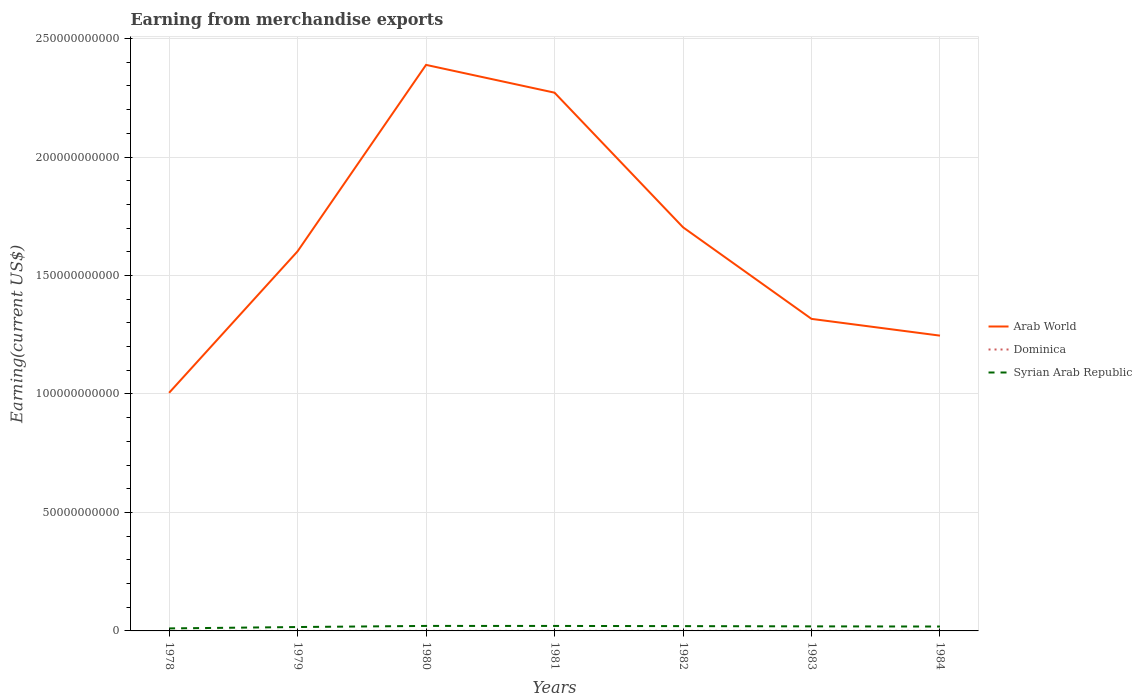Does the line corresponding to Dominica intersect with the line corresponding to Syrian Arab Republic?
Ensure brevity in your answer.  No. Is the number of lines equal to the number of legend labels?
Offer a terse response. Yes. Across all years, what is the maximum amount earned from merchandise exports in Syrian Arab Republic?
Keep it short and to the point. 1.06e+09. In which year was the amount earned from merchandise exports in Dominica maximum?
Your response must be concise. 1979. What is the total amount earned from merchandise exports in Dominica in the graph?
Provide a succinct answer. -1.70e+07. What is the difference between the highest and the second highest amount earned from merchandise exports in Dominica?
Make the answer very short. 1.76e+07. Is the amount earned from merchandise exports in Syrian Arab Republic strictly greater than the amount earned from merchandise exports in Dominica over the years?
Offer a terse response. No. How many lines are there?
Your answer should be very brief. 3. How many years are there in the graph?
Offer a terse response. 7. Does the graph contain grids?
Offer a terse response. Yes. What is the title of the graph?
Ensure brevity in your answer.  Earning from merchandise exports. What is the label or title of the Y-axis?
Your response must be concise. Earning(current US$). What is the Earning(current US$) in Arab World in 1978?
Provide a succinct answer. 1.00e+11. What is the Earning(current US$) of Dominica in 1978?
Ensure brevity in your answer.  1.59e+07. What is the Earning(current US$) of Syrian Arab Republic in 1978?
Make the answer very short. 1.06e+09. What is the Earning(current US$) in Arab World in 1979?
Make the answer very short. 1.60e+11. What is the Earning(current US$) in Dominica in 1979?
Keep it short and to the point. 9.40e+06. What is the Earning(current US$) in Syrian Arab Republic in 1979?
Offer a very short reply. 1.64e+09. What is the Earning(current US$) in Arab World in 1980?
Make the answer very short. 2.39e+11. What is the Earning(current US$) of Syrian Arab Republic in 1980?
Provide a succinct answer. 2.11e+09. What is the Earning(current US$) in Arab World in 1981?
Ensure brevity in your answer.  2.27e+11. What is the Earning(current US$) in Dominica in 1981?
Make the answer very short. 1.90e+07. What is the Earning(current US$) in Syrian Arab Republic in 1981?
Keep it short and to the point. 2.10e+09. What is the Earning(current US$) of Arab World in 1982?
Your response must be concise. 1.70e+11. What is the Earning(current US$) in Dominica in 1982?
Your answer should be very brief. 2.40e+07. What is the Earning(current US$) of Syrian Arab Republic in 1982?
Offer a very short reply. 2.03e+09. What is the Earning(current US$) in Arab World in 1983?
Give a very brief answer. 1.32e+11. What is the Earning(current US$) of Dominica in 1983?
Your response must be concise. 2.70e+07. What is the Earning(current US$) of Syrian Arab Republic in 1983?
Keep it short and to the point. 1.92e+09. What is the Earning(current US$) in Arab World in 1984?
Offer a terse response. 1.25e+11. What is the Earning(current US$) of Dominica in 1984?
Offer a very short reply. 2.60e+07. What is the Earning(current US$) of Syrian Arab Republic in 1984?
Provide a succinct answer. 1.85e+09. Across all years, what is the maximum Earning(current US$) in Arab World?
Offer a very short reply. 2.39e+11. Across all years, what is the maximum Earning(current US$) in Dominica?
Provide a succinct answer. 2.70e+07. Across all years, what is the maximum Earning(current US$) of Syrian Arab Republic?
Offer a terse response. 2.11e+09. Across all years, what is the minimum Earning(current US$) in Arab World?
Ensure brevity in your answer.  1.00e+11. Across all years, what is the minimum Earning(current US$) in Dominica?
Provide a succinct answer. 9.40e+06. Across all years, what is the minimum Earning(current US$) of Syrian Arab Republic?
Offer a terse response. 1.06e+09. What is the total Earning(current US$) in Arab World in the graph?
Keep it short and to the point. 1.15e+12. What is the total Earning(current US$) in Dominica in the graph?
Ensure brevity in your answer.  1.31e+08. What is the total Earning(current US$) in Syrian Arab Republic in the graph?
Give a very brief answer. 1.27e+1. What is the difference between the Earning(current US$) in Arab World in 1978 and that in 1979?
Give a very brief answer. -5.97e+1. What is the difference between the Earning(current US$) in Dominica in 1978 and that in 1979?
Your answer should be very brief. 6.48e+06. What is the difference between the Earning(current US$) in Syrian Arab Republic in 1978 and that in 1979?
Your answer should be very brief. -5.84e+08. What is the difference between the Earning(current US$) in Arab World in 1978 and that in 1980?
Ensure brevity in your answer.  -1.38e+11. What is the difference between the Earning(current US$) of Dominica in 1978 and that in 1980?
Provide a succinct answer. 5.89e+06. What is the difference between the Earning(current US$) of Syrian Arab Republic in 1978 and that in 1980?
Keep it short and to the point. -1.05e+09. What is the difference between the Earning(current US$) of Arab World in 1978 and that in 1981?
Offer a terse response. -1.27e+11. What is the difference between the Earning(current US$) in Dominica in 1978 and that in 1981?
Your response must be concise. -3.11e+06. What is the difference between the Earning(current US$) in Syrian Arab Republic in 1978 and that in 1981?
Offer a terse response. -1.04e+09. What is the difference between the Earning(current US$) of Arab World in 1978 and that in 1982?
Offer a very short reply. -6.99e+1. What is the difference between the Earning(current US$) in Dominica in 1978 and that in 1982?
Provide a short and direct response. -8.11e+06. What is the difference between the Earning(current US$) in Syrian Arab Republic in 1978 and that in 1982?
Your answer should be compact. -9.66e+08. What is the difference between the Earning(current US$) in Arab World in 1978 and that in 1983?
Provide a succinct answer. -3.12e+1. What is the difference between the Earning(current US$) of Dominica in 1978 and that in 1983?
Keep it short and to the point. -1.11e+07. What is the difference between the Earning(current US$) of Syrian Arab Republic in 1978 and that in 1983?
Provide a short and direct response. -8.63e+08. What is the difference between the Earning(current US$) in Arab World in 1978 and that in 1984?
Offer a very short reply. -2.41e+1. What is the difference between the Earning(current US$) in Dominica in 1978 and that in 1984?
Provide a short and direct response. -1.01e+07. What is the difference between the Earning(current US$) in Syrian Arab Republic in 1978 and that in 1984?
Provide a succinct answer. -7.93e+08. What is the difference between the Earning(current US$) in Arab World in 1979 and that in 1980?
Offer a very short reply. -7.87e+1. What is the difference between the Earning(current US$) of Dominica in 1979 and that in 1980?
Your answer should be compact. -5.96e+05. What is the difference between the Earning(current US$) in Syrian Arab Republic in 1979 and that in 1980?
Offer a very short reply. -4.64e+08. What is the difference between the Earning(current US$) of Arab World in 1979 and that in 1981?
Ensure brevity in your answer.  -6.70e+1. What is the difference between the Earning(current US$) of Dominica in 1979 and that in 1981?
Provide a short and direct response. -9.60e+06. What is the difference between the Earning(current US$) of Syrian Arab Republic in 1979 and that in 1981?
Your answer should be compact. -4.59e+08. What is the difference between the Earning(current US$) of Arab World in 1979 and that in 1982?
Provide a succinct answer. -1.02e+1. What is the difference between the Earning(current US$) in Dominica in 1979 and that in 1982?
Offer a very short reply. -1.46e+07. What is the difference between the Earning(current US$) of Syrian Arab Republic in 1979 and that in 1982?
Your answer should be very brief. -3.82e+08. What is the difference between the Earning(current US$) in Arab World in 1979 and that in 1983?
Ensure brevity in your answer.  2.85e+1. What is the difference between the Earning(current US$) of Dominica in 1979 and that in 1983?
Offer a terse response. -1.76e+07. What is the difference between the Earning(current US$) in Syrian Arab Republic in 1979 and that in 1983?
Your answer should be very brief. -2.79e+08. What is the difference between the Earning(current US$) of Arab World in 1979 and that in 1984?
Provide a succinct answer. 3.56e+1. What is the difference between the Earning(current US$) of Dominica in 1979 and that in 1984?
Offer a terse response. -1.66e+07. What is the difference between the Earning(current US$) in Syrian Arab Republic in 1979 and that in 1984?
Ensure brevity in your answer.  -2.09e+08. What is the difference between the Earning(current US$) of Arab World in 1980 and that in 1981?
Give a very brief answer. 1.17e+1. What is the difference between the Earning(current US$) of Dominica in 1980 and that in 1981?
Your answer should be compact. -9.00e+06. What is the difference between the Earning(current US$) in Arab World in 1980 and that in 1982?
Offer a very short reply. 6.85e+1. What is the difference between the Earning(current US$) of Dominica in 1980 and that in 1982?
Offer a very short reply. -1.40e+07. What is the difference between the Earning(current US$) in Syrian Arab Republic in 1980 and that in 1982?
Ensure brevity in your answer.  8.20e+07. What is the difference between the Earning(current US$) of Arab World in 1980 and that in 1983?
Offer a terse response. 1.07e+11. What is the difference between the Earning(current US$) in Dominica in 1980 and that in 1983?
Make the answer very short. -1.70e+07. What is the difference between the Earning(current US$) in Syrian Arab Republic in 1980 and that in 1983?
Provide a short and direct response. 1.85e+08. What is the difference between the Earning(current US$) of Arab World in 1980 and that in 1984?
Give a very brief answer. 1.14e+11. What is the difference between the Earning(current US$) of Dominica in 1980 and that in 1984?
Your answer should be compact. -1.60e+07. What is the difference between the Earning(current US$) of Syrian Arab Republic in 1980 and that in 1984?
Keep it short and to the point. 2.55e+08. What is the difference between the Earning(current US$) in Arab World in 1981 and that in 1982?
Keep it short and to the point. 5.68e+1. What is the difference between the Earning(current US$) of Dominica in 1981 and that in 1982?
Your answer should be compact. -5.00e+06. What is the difference between the Earning(current US$) in Syrian Arab Republic in 1981 and that in 1982?
Make the answer very short. 7.70e+07. What is the difference between the Earning(current US$) of Arab World in 1981 and that in 1983?
Your response must be concise. 9.55e+1. What is the difference between the Earning(current US$) in Dominica in 1981 and that in 1983?
Provide a succinct answer. -8.00e+06. What is the difference between the Earning(current US$) in Syrian Arab Republic in 1981 and that in 1983?
Provide a succinct answer. 1.80e+08. What is the difference between the Earning(current US$) in Arab World in 1981 and that in 1984?
Your answer should be very brief. 1.03e+11. What is the difference between the Earning(current US$) in Dominica in 1981 and that in 1984?
Keep it short and to the point. -7.00e+06. What is the difference between the Earning(current US$) of Syrian Arab Republic in 1981 and that in 1984?
Provide a short and direct response. 2.50e+08. What is the difference between the Earning(current US$) in Arab World in 1982 and that in 1983?
Your response must be concise. 3.87e+1. What is the difference between the Earning(current US$) of Syrian Arab Republic in 1982 and that in 1983?
Ensure brevity in your answer.  1.03e+08. What is the difference between the Earning(current US$) in Arab World in 1982 and that in 1984?
Make the answer very short. 4.57e+1. What is the difference between the Earning(current US$) of Syrian Arab Republic in 1982 and that in 1984?
Your answer should be very brief. 1.73e+08. What is the difference between the Earning(current US$) in Arab World in 1983 and that in 1984?
Your response must be concise. 7.07e+09. What is the difference between the Earning(current US$) of Syrian Arab Republic in 1983 and that in 1984?
Offer a very short reply. 7.00e+07. What is the difference between the Earning(current US$) in Arab World in 1978 and the Earning(current US$) in Dominica in 1979?
Keep it short and to the point. 1.00e+11. What is the difference between the Earning(current US$) in Arab World in 1978 and the Earning(current US$) in Syrian Arab Republic in 1979?
Offer a very short reply. 9.88e+1. What is the difference between the Earning(current US$) of Dominica in 1978 and the Earning(current US$) of Syrian Arab Republic in 1979?
Your response must be concise. -1.63e+09. What is the difference between the Earning(current US$) of Arab World in 1978 and the Earning(current US$) of Dominica in 1980?
Provide a succinct answer. 1.00e+11. What is the difference between the Earning(current US$) of Arab World in 1978 and the Earning(current US$) of Syrian Arab Republic in 1980?
Make the answer very short. 9.84e+1. What is the difference between the Earning(current US$) of Dominica in 1978 and the Earning(current US$) of Syrian Arab Republic in 1980?
Your response must be concise. -2.09e+09. What is the difference between the Earning(current US$) of Arab World in 1978 and the Earning(current US$) of Dominica in 1981?
Give a very brief answer. 1.00e+11. What is the difference between the Earning(current US$) in Arab World in 1978 and the Earning(current US$) in Syrian Arab Republic in 1981?
Offer a terse response. 9.84e+1. What is the difference between the Earning(current US$) in Dominica in 1978 and the Earning(current US$) in Syrian Arab Republic in 1981?
Your answer should be compact. -2.09e+09. What is the difference between the Earning(current US$) in Arab World in 1978 and the Earning(current US$) in Dominica in 1982?
Provide a short and direct response. 1.00e+11. What is the difference between the Earning(current US$) in Arab World in 1978 and the Earning(current US$) in Syrian Arab Republic in 1982?
Your answer should be very brief. 9.85e+1. What is the difference between the Earning(current US$) of Dominica in 1978 and the Earning(current US$) of Syrian Arab Republic in 1982?
Give a very brief answer. -2.01e+09. What is the difference between the Earning(current US$) of Arab World in 1978 and the Earning(current US$) of Dominica in 1983?
Your answer should be very brief. 1.00e+11. What is the difference between the Earning(current US$) of Arab World in 1978 and the Earning(current US$) of Syrian Arab Republic in 1983?
Your answer should be very brief. 9.86e+1. What is the difference between the Earning(current US$) in Dominica in 1978 and the Earning(current US$) in Syrian Arab Republic in 1983?
Give a very brief answer. -1.91e+09. What is the difference between the Earning(current US$) in Arab World in 1978 and the Earning(current US$) in Dominica in 1984?
Make the answer very short. 1.00e+11. What is the difference between the Earning(current US$) of Arab World in 1978 and the Earning(current US$) of Syrian Arab Republic in 1984?
Provide a succinct answer. 9.86e+1. What is the difference between the Earning(current US$) of Dominica in 1978 and the Earning(current US$) of Syrian Arab Republic in 1984?
Keep it short and to the point. -1.84e+09. What is the difference between the Earning(current US$) in Arab World in 1979 and the Earning(current US$) in Dominica in 1980?
Your answer should be compact. 1.60e+11. What is the difference between the Earning(current US$) in Arab World in 1979 and the Earning(current US$) in Syrian Arab Republic in 1980?
Provide a short and direct response. 1.58e+11. What is the difference between the Earning(current US$) in Dominica in 1979 and the Earning(current US$) in Syrian Arab Republic in 1980?
Make the answer very short. -2.10e+09. What is the difference between the Earning(current US$) in Arab World in 1979 and the Earning(current US$) in Dominica in 1981?
Offer a very short reply. 1.60e+11. What is the difference between the Earning(current US$) in Arab World in 1979 and the Earning(current US$) in Syrian Arab Republic in 1981?
Offer a terse response. 1.58e+11. What is the difference between the Earning(current US$) of Dominica in 1979 and the Earning(current US$) of Syrian Arab Republic in 1981?
Your answer should be very brief. -2.09e+09. What is the difference between the Earning(current US$) of Arab World in 1979 and the Earning(current US$) of Dominica in 1982?
Make the answer very short. 1.60e+11. What is the difference between the Earning(current US$) in Arab World in 1979 and the Earning(current US$) in Syrian Arab Republic in 1982?
Offer a terse response. 1.58e+11. What is the difference between the Earning(current US$) of Dominica in 1979 and the Earning(current US$) of Syrian Arab Republic in 1982?
Ensure brevity in your answer.  -2.02e+09. What is the difference between the Earning(current US$) in Arab World in 1979 and the Earning(current US$) in Dominica in 1983?
Provide a short and direct response. 1.60e+11. What is the difference between the Earning(current US$) in Arab World in 1979 and the Earning(current US$) in Syrian Arab Republic in 1983?
Offer a terse response. 1.58e+11. What is the difference between the Earning(current US$) of Dominica in 1979 and the Earning(current US$) of Syrian Arab Republic in 1983?
Your answer should be compact. -1.91e+09. What is the difference between the Earning(current US$) in Arab World in 1979 and the Earning(current US$) in Dominica in 1984?
Offer a terse response. 1.60e+11. What is the difference between the Earning(current US$) of Arab World in 1979 and the Earning(current US$) of Syrian Arab Republic in 1984?
Keep it short and to the point. 1.58e+11. What is the difference between the Earning(current US$) of Dominica in 1979 and the Earning(current US$) of Syrian Arab Republic in 1984?
Give a very brief answer. -1.84e+09. What is the difference between the Earning(current US$) in Arab World in 1980 and the Earning(current US$) in Dominica in 1981?
Your response must be concise. 2.39e+11. What is the difference between the Earning(current US$) of Arab World in 1980 and the Earning(current US$) of Syrian Arab Republic in 1981?
Give a very brief answer. 2.37e+11. What is the difference between the Earning(current US$) in Dominica in 1980 and the Earning(current US$) in Syrian Arab Republic in 1981?
Make the answer very short. -2.09e+09. What is the difference between the Earning(current US$) in Arab World in 1980 and the Earning(current US$) in Dominica in 1982?
Offer a very short reply. 2.39e+11. What is the difference between the Earning(current US$) in Arab World in 1980 and the Earning(current US$) in Syrian Arab Republic in 1982?
Offer a very short reply. 2.37e+11. What is the difference between the Earning(current US$) in Dominica in 1980 and the Earning(current US$) in Syrian Arab Republic in 1982?
Offer a very short reply. -2.02e+09. What is the difference between the Earning(current US$) of Arab World in 1980 and the Earning(current US$) of Dominica in 1983?
Keep it short and to the point. 2.39e+11. What is the difference between the Earning(current US$) in Arab World in 1980 and the Earning(current US$) in Syrian Arab Republic in 1983?
Provide a short and direct response. 2.37e+11. What is the difference between the Earning(current US$) of Dominica in 1980 and the Earning(current US$) of Syrian Arab Republic in 1983?
Your answer should be compact. -1.91e+09. What is the difference between the Earning(current US$) in Arab World in 1980 and the Earning(current US$) in Dominica in 1984?
Provide a short and direct response. 2.39e+11. What is the difference between the Earning(current US$) in Arab World in 1980 and the Earning(current US$) in Syrian Arab Republic in 1984?
Offer a very short reply. 2.37e+11. What is the difference between the Earning(current US$) in Dominica in 1980 and the Earning(current US$) in Syrian Arab Republic in 1984?
Provide a short and direct response. -1.84e+09. What is the difference between the Earning(current US$) of Arab World in 1981 and the Earning(current US$) of Dominica in 1982?
Offer a very short reply. 2.27e+11. What is the difference between the Earning(current US$) of Arab World in 1981 and the Earning(current US$) of Syrian Arab Republic in 1982?
Offer a very short reply. 2.25e+11. What is the difference between the Earning(current US$) in Dominica in 1981 and the Earning(current US$) in Syrian Arab Republic in 1982?
Your answer should be compact. -2.01e+09. What is the difference between the Earning(current US$) in Arab World in 1981 and the Earning(current US$) in Dominica in 1983?
Make the answer very short. 2.27e+11. What is the difference between the Earning(current US$) in Arab World in 1981 and the Earning(current US$) in Syrian Arab Republic in 1983?
Ensure brevity in your answer.  2.25e+11. What is the difference between the Earning(current US$) of Dominica in 1981 and the Earning(current US$) of Syrian Arab Republic in 1983?
Your response must be concise. -1.90e+09. What is the difference between the Earning(current US$) in Arab World in 1981 and the Earning(current US$) in Dominica in 1984?
Offer a very short reply. 2.27e+11. What is the difference between the Earning(current US$) of Arab World in 1981 and the Earning(current US$) of Syrian Arab Republic in 1984?
Make the answer very short. 2.25e+11. What is the difference between the Earning(current US$) of Dominica in 1981 and the Earning(current US$) of Syrian Arab Republic in 1984?
Provide a succinct answer. -1.83e+09. What is the difference between the Earning(current US$) in Arab World in 1982 and the Earning(current US$) in Dominica in 1983?
Ensure brevity in your answer.  1.70e+11. What is the difference between the Earning(current US$) of Arab World in 1982 and the Earning(current US$) of Syrian Arab Republic in 1983?
Ensure brevity in your answer.  1.68e+11. What is the difference between the Earning(current US$) of Dominica in 1982 and the Earning(current US$) of Syrian Arab Republic in 1983?
Your answer should be compact. -1.90e+09. What is the difference between the Earning(current US$) in Arab World in 1982 and the Earning(current US$) in Dominica in 1984?
Make the answer very short. 1.70e+11. What is the difference between the Earning(current US$) of Arab World in 1982 and the Earning(current US$) of Syrian Arab Republic in 1984?
Provide a short and direct response. 1.68e+11. What is the difference between the Earning(current US$) of Dominica in 1982 and the Earning(current US$) of Syrian Arab Republic in 1984?
Offer a terse response. -1.83e+09. What is the difference between the Earning(current US$) of Arab World in 1983 and the Earning(current US$) of Dominica in 1984?
Provide a succinct answer. 1.32e+11. What is the difference between the Earning(current US$) of Arab World in 1983 and the Earning(current US$) of Syrian Arab Republic in 1984?
Give a very brief answer. 1.30e+11. What is the difference between the Earning(current US$) in Dominica in 1983 and the Earning(current US$) in Syrian Arab Republic in 1984?
Make the answer very short. -1.83e+09. What is the average Earning(current US$) in Arab World per year?
Offer a very short reply. 1.65e+11. What is the average Earning(current US$) in Dominica per year?
Your response must be concise. 1.88e+07. What is the average Earning(current US$) in Syrian Arab Republic per year?
Offer a terse response. 1.82e+09. In the year 1978, what is the difference between the Earning(current US$) of Arab World and Earning(current US$) of Dominica?
Your answer should be compact. 1.00e+11. In the year 1978, what is the difference between the Earning(current US$) in Arab World and Earning(current US$) in Syrian Arab Republic?
Offer a very short reply. 9.94e+1. In the year 1978, what is the difference between the Earning(current US$) in Dominica and Earning(current US$) in Syrian Arab Republic?
Provide a succinct answer. -1.04e+09. In the year 1979, what is the difference between the Earning(current US$) of Arab World and Earning(current US$) of Dominica?
Ensure brevity in your answer.  1.60e+11. In the year 1979, what is the difference between the Earning(current US$) in Arab World and Earning(current US$) in Syrian Arab Republic?
Your response must be concise. 1.59e+11. In the year 1979, what is the difference between the Earning(current US$) of Dominica and Earning(current US$) of Syrian Arab Republic?
Offer a terse response. -1.63e+09. In the year 1980, what is the difference between the Earning(current US$) of Arab World and Earning(current US$) of Dominica?
Keep it short and to the point. 2.39e+11. In the year 1980, what is the difference between the Earning(current US$) of Arab World and Earning(current US$) of Syrian Arab Republic?
Provide a short and direct response. 2.37e+11. In the year 1980, what is the difference between the Earning(current US$) in Dominica and Earning(current US$) in Syrian Arab Republic?
Offer a very short reply. -2.10e+09. In the year 1981, what is the difference between the Earning(current US$) of Arab World and Earning(current US$) of Dominica?
Your response must be concise. 2.27e+11. In the year 1981, what is the difference between the Earning(current US$) in Arab World and Earning(current US$) in Syrian Arab Republic?
Your response must be concise. 2.25e+11. In the year 1981, what is the difference between the Earning(current US$) of Dominica and Earning(current US$) of Syrian Arab Republic?
Offer a very short reply. -2.08e+09. In the year 1982, what is the difference between the Earning(current US$) in Arab World and Earning(current US$) in Dominica?
Keep it short and to the point. 1.70e+11. In the year 1982, what is the difference between the Earning(current US$) of Arab World and Earning(current US$) of Syrian Arab Republic?
Provide a succinct answer. 1.68e+11. In the year 1982, what is the difference between the Earning(current US$) of Dominica and Earning(current US$) of Syrian Arab Republic?
Provide a short and direct response. -2.00e+09. In the year 1983, what is the difference between the Earning(current US$) of Arab World and Earning(current US$) of Dominica?
Give a very brief answer. 1.32e+11. In the year 1983, what is the difference between the Earning(current US$) in Arab World and Earning(current US$) in Syrian Arab Republic?
Give a very brief answer. 1.30e+11. In the year 1983, what is the difference between the Earning(current US$) of Dominica and Earning(current US$) of Syrian Arab Republic?
Your answer should be very brief. -1.90e+09. In the year 1984, what is the difference between the Earning(current US$) of Arab World and Earning(current US$) of Dominica?
Give a very brief answer. 1.25e+11. In the year 1984, what is the difference between the Earning(current US$) of Arab World and Earning(current US$) of Syrian Arab Republic?
Your response must be concise. 1.23e+11. In the year 1984, what is the difference between the Earning(current US$) of Dominica and Earning(current US$) of Syrian Arab Republic?
Keep it short and to the point. -1.83e+09. What is the ratio of the Earning(current US$) of Arab World in 1978 to that in 1979?
Give a very brief answer. 0.63. What is the ratio of the Earning(current US$) of Dominica in 1978 to that in 1979?
Your answer should be very brief. 1.69. What is the ratio of the Earning(current US$) of Syrian Arab Republic in 1978 to that in 1979?
Offer a very short reply. 0.64. What is the ratio of the Earning(current US$) in Arab World in 1978 to that in 1980?
Offer a terse response. 0.42. What is the ratio of the Earning(current US$) in Dominica in 1978 to that in 1980?
Offer a terse response. 1.59. What is the ratio of the Earning(current US$) in Syrian Arab Republic in 1978 to that in 1980?
Provide a short and direct response. 0.5. What is the ratio of the Earning(current US$) in Arab World in 1978 to that in 1981?
Make the answer very short. 0.44. What is the ratio of the Earning(current US$) in Dominica in 1978 to that in 1981?
Provide a short and direct response. 0.84. What is the ratio of the Earning(current US$) in Syrian Arab Republic in 1978 to that in 1981?
Your response must be concise. 0.5. What is the ratio of the Earning(current US$) in Arab World in 1978 to that in 1982?
Your answer should be compact. 0.59. What is the ratio of the Earning(current US$) of Dominica in 1978 to that in 1982?
Your response must be concise. 0.66. What is the ratio of the Earning(current US$) of Syrian Arab Republic in 1978 to that in 1982?
Make the answer very short. 0.52. What is the ratio of the Earning(current US$) of Arab World in 1978 to that in 1983?
Provide a succinct answer. 0.76. What is the ratio of the Earning(current US$) in Dominica in 1978 to that in 1983?
Give a very brief answer. 0.59. What is the ratio of the Earning(current US$) of Syrian Arab Republic in 1978 to that in 1983?
Provide a succinct answer. 0.55. What is the ratio of the Earning(current US$) of Arab World in 1978 to that in 1984?
Provide a succinct answer. 0.81. What is the ratio of the Earning(current US$) of Dominica in 1978 to that in 1984?
Your answer should be very brief. 0.61. What is the ratio of the Earning(current US$) of Syrian Arab Republic in 1978 to that in 1984?
Your response must be concise. 0.57. What is the ratio of the Earning(current US$) of Arab World in 1979 to that in 1980?
Give a very brief answer. 0.67. What is the ratio of the Earning(current US$) in Dominica in 1979 to that in 1980?
Provide a short and direct response. 0.94. What is the ratio of the Earning(current US$) of Syrian Arab Republic in 1979 to that in 1980?
Keep it short and to the point. 0.78. What is the ratio of the Earning(current US$) in Arab World in 1979 to that in 1981?
Ensure brevity in your answer.  0.71. What is the ratio of the Earning(current US$) in Dominica in 1979 to that in 1981?
Your answer should be very brief. 0.49. What is the ratio of the Earning(current US$) of Syrian Arab Republic in 1979 to that in 1981?
Provide a short and direct response. 0.78. What is the ratio of the Earning(current US$) of Arab World in 1979 to that in 1982?
Ensure brevity in your answer.  0.94. What is the ratio of the Earning(current US$) in Dominica in 1979 to that in 1982?
Your answer should be very brief. 0.39. What is the ratio of the Earning(current US$) of Syrian Arab Republic in 1979 to that in 1982?
Give a very brief answer. 0.81. What is the ratio of the Earning(current US$) in Arab World in 1979 to that in 1983?
Offer a very short reply. 1.22. What is the ratio of the Earning(current US$) in Dominica in 1979 to that in 1983?
Give a very brief answer. 0.35. What is the ratio of the Earning(current US$) of Syrian Arab Republic in 1979 to that in 1983?
Give a very brief answer. 0.85. What is the ratio of the Earning(current US$) in Arab World in 1979 to that in 1984?
Offer a very short reply. 1.29. What is the ratio of the Earning(current US$) in Dominica in 1979 to that in 1984?
Offer a very short reply. 0.36. What is the ratio of the Earning(current US$) in Syrian Arab Republic in 1979 to that in 1984?
Make the answer very short. 0.89. What is the ratio of the Earning(current US$) in Arab World in 1980 to that in 1981?
Offer a terse response. 1.05. What is the ratio of the Earning(current US$) in Dominica in 1980 to that in 1981?
Give a very brief answer. 0.53. What is the ratio of the Earning(current US$) in Arab World in 1980 to that in 1982?
Your response must be concise. 1.4. What is the ratio of the Earning(current US$) in Dominica in 1980 to that in 1982?
Keep it short and to the point. 0.42. What is the ratio of the Earning(current US$) in Syrian Arab Republic in 1980 to that in 1982?
Your response must be concise. 1.04. What is the ratio of the Earning(current US$) of Arab World in 1980 to that in 1983?
Your answer should be very brief. 1.81. What is the ratio of the Earning(current US$) of Dominica in 1980 to that in 1983?
Your answer should be compact. 0.37. What is the ratio of the Earning(current US$) in Syrian Arab Republic in 1980 to that in 1983?
Give a very brief answer. 1.1. What is the ratio of the Earning(current US$) of Arab World in 1980 to that in 1984?
Offer a very short reply. 1.92. What is the ratio of the Earning(current US$) in Dominica in 1980 to that in 1984?
Your response must be concise. 0.38. What is the ratio of the Earning(current US$) in Syrian Arab Republic in 1980 to that in 1984?
Provide a succinct answer. 1.14. What is the ratio of the Earning(current US$) in Arab World in 1981 to that in 1982?
Your answer should be very brief. 1.33. What is the ratio of the Earning(current US$) in Dominica in 1981 to that in 1982?
Keep it short and to the point. 0.79. What is the ratio of the Earning(current US$) in Syrian Arab Republic in 1981 to that in 1982?
Give a very brief answer. 1.04. What is the ratio of the Earning(current US$) of Arab World in 1981 to that in 1983?
Offer a very short reply. 1.72. What is the ratio of the Earning(current US$) of Dominica in 1981 to that in 1983?
Offer a very short reply. 0.7. What is the ratio of the Earning(current US$) of Syrian Arab Republic in 1981 to that in 1983?
Ensure brevity in your answer.  1.09. What is the ratio of the Earning(current US$) of Arab World in 1981 to that in 1984?
Your answer should be very brief. 1.82. What is the ratio of the Earning(current US$) of Dominica in 1981 to that in 1984?
Your answer should be compact. 0.73. What is the ratio of the Earning(current US$) in Syrian Arab Republic in 1981 to that in 1984?
Make the answer very short. 1.13. What is the ratio of the Earning(current US$) of Arab World in 1982 to that in 1983?
Your answer should be very brief. 1.29. What is the ratio of the Earning(current US$) of Syrian Arab Republic in 1982 to that in 1983?
Provide a short and direct response. 1.05. What is the ratio of the Earning(current US$) in Arab World in 1982 to that in 1984?
Ensure brevity in your answer.  1.37. What is the ratio of the Earning(current US$) of Dominica in 1982 to that in 1984?
Offer a very short reply. 0.92. What is the ratio of the Earning(current US$) in Syrian Arab Republic in 1982 to that in 1984?
Your answer should be compact. 1.09. What is the ratio of the Earning(current US$) of Arab World in 1983 to that in 1984?
Offer a terse response. 1.06. What is the ratio of the Earning(current US$) in Dominica in 1983 to that in 1984?
Keep it short and to the point. 1.04. What is the ratio of the Earning(current US$) of Syrian Arab Republic in 1983 to that in 1984?
Offer a terse response. 1.04. What is the difference between the highest and the second highest Earning(current US$) of Arab World?
Your answer should be compact. 1.17e+1. What is the difference between the highest and the second highest Earning(current US$) of Dominica?
Give a very brief answer. 1.00e+06. What is the difference between the highest and the second highest Earning(current US$) in Syrian Arab Republic?
Make the answer very short. 5.00e+06. What is the difference between the highest and the lowest Earning(current US$) in Arab World?
Offer a terse response. 1.38e+11. What is the difference between the highest and the lowest Earning(current US$) in Dominica?
Your response must be concise. 1.76e+07. What is the difference between the highest and the lowest Earning(current US$) in Syrian Arab Republic?
Give a very brief answer. 1.05e+09. 